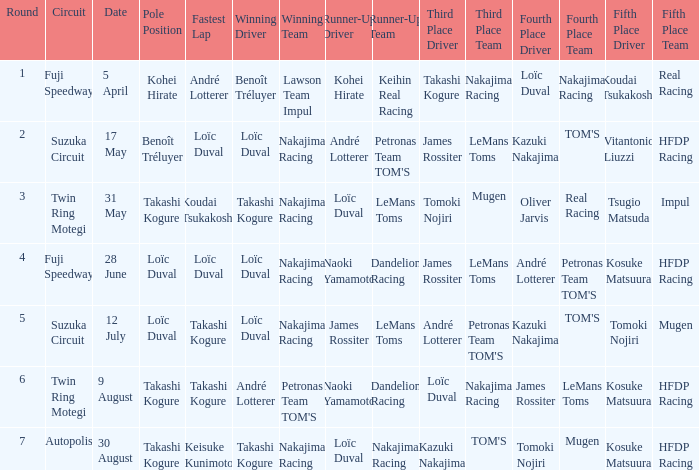How many drivers drove on Suzuka Circuit where Loïc Duval took pole position? 1.0. 